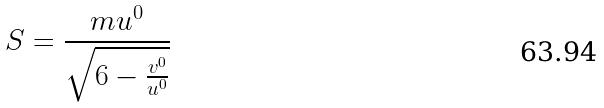<formula> <loc_0><loc_0><loc_500><loc_500>S = \frac { m u ^ { 0 } } { \sqrt { 6 - \frac { v ^ { 0 } } { u ^ { 0 } } } }</formula> 